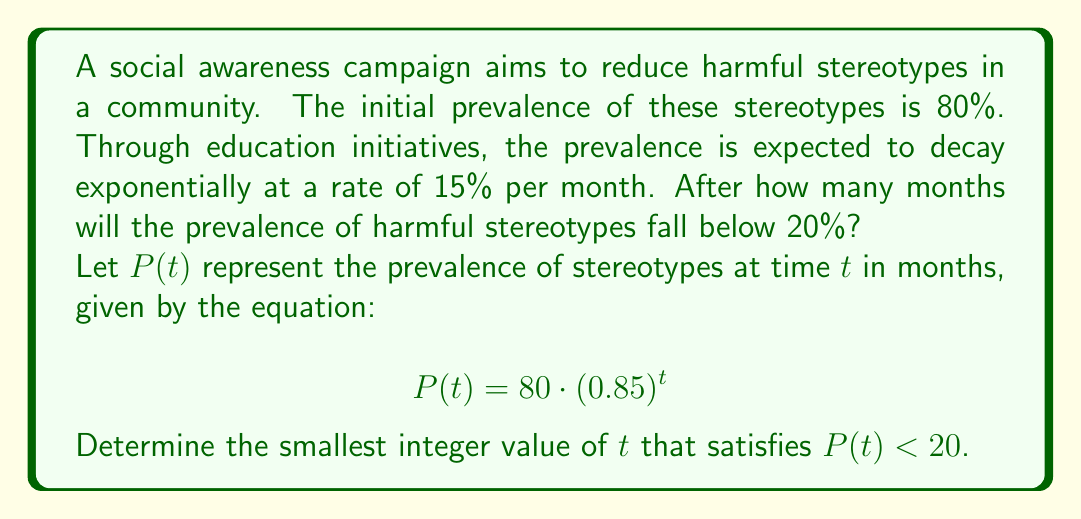What is the answer to this math problem? To solve this problem, we'll follow these steps:

1) We start with the exponential decay equation:
   $$P(t) = 80 \cdot (0.85)^t$$

2) We want to find when $P(t) < 20$, so we set up the inequality:
   $$80 \cdot (0.85)^t < 20$$

3) Divide both sides by 80:
   $$(0.85)^t < \frac{1}{4}$$

4) Take the natural log of both sides:
   $$t \cdot \ln(0.85) < \ln(\frac{1}{4})$$

5) Divide both sides by $\ln(0.85)$ (note that this flips the inequality because $\ln(0.85)$ is negative):
   $$t > \frac{\ln(\frac{1}{4})}{\ln(0.85)}$$

6) Calculate the right-hand side:
   $$t > \frac{\ln(0.25)}{\ln(0.85)} \approx 8.7589$$

7) Since we need the smallest integer value of $t$, we round up to the next whole number.
Answer: 9 months 